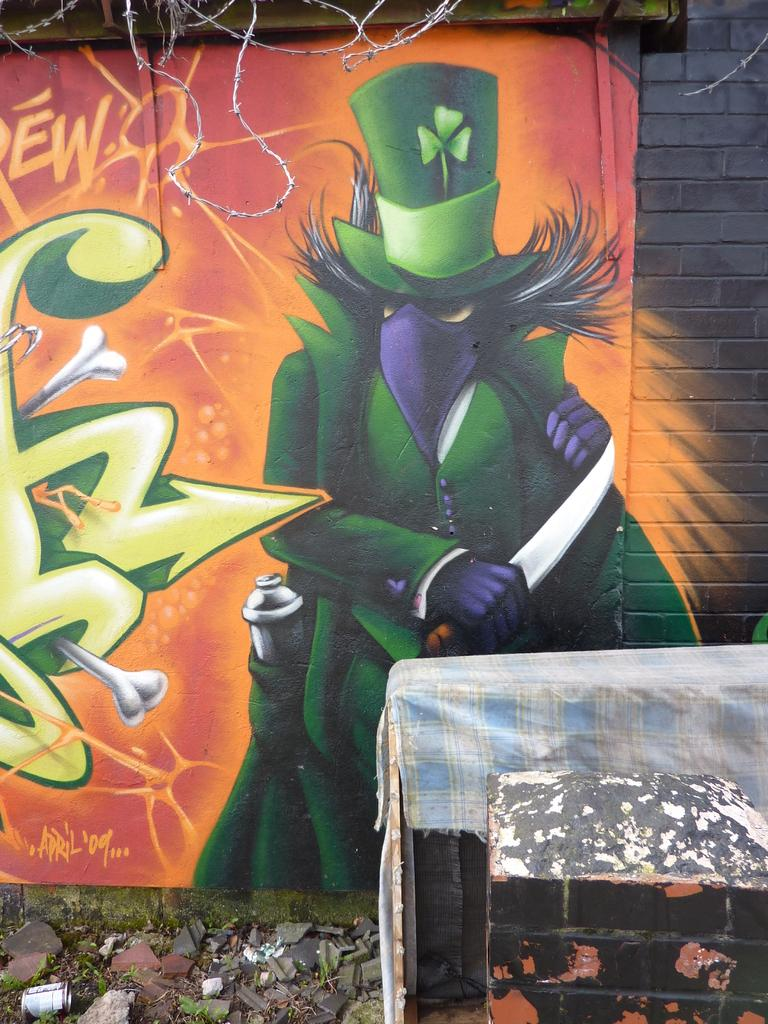What is hanging on the wall in the image? There is a painting on the wall in the image. What can be seen at the bottom of the image? There are stones at the bottom of the image. What is located to the right side of the image? There is an object with cloth on it to the right side of the image. What type of structure is present in the image? There is a pillar in the image. Can you see a window in the image? There is no window present in the image. What type of system is being used to transport the cloth in the image? There is no system for transporting cloth visible in the image; it is simply draped over an object. 